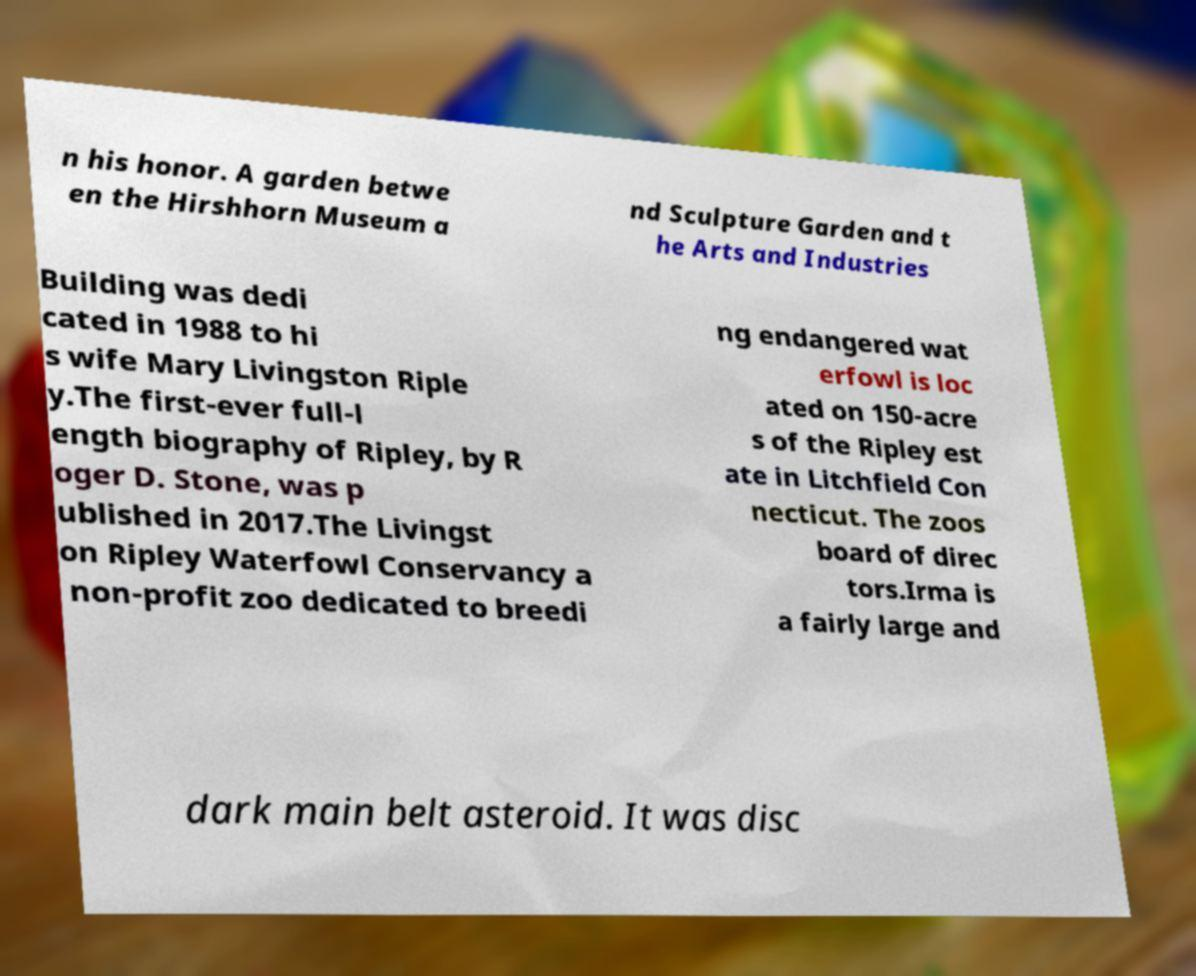Could you assist in decoding the text presented in this image and type it out clearly? n his honor. A garden betwe en the Hirshhorn Museum a nd Sculpture Garden and t he Arts and Industries Building was dedi cated in 1988 to hi s wife Mary Livingston Riple y.The first-ever full-l ength biography of Ripley, by R oger D. Stone, was p ublished in 2017.The Livingst on Ripley Waterfowl Conservancy a non-profit zoo dedicated to breedi ng endangered wat erfowl is loc ated on 150-acre s of the Ripley est ate in Litchfield Con necticut. The zoos board of direc tors.Irma is a fairly large and dark main belt asteroid. It was disc 